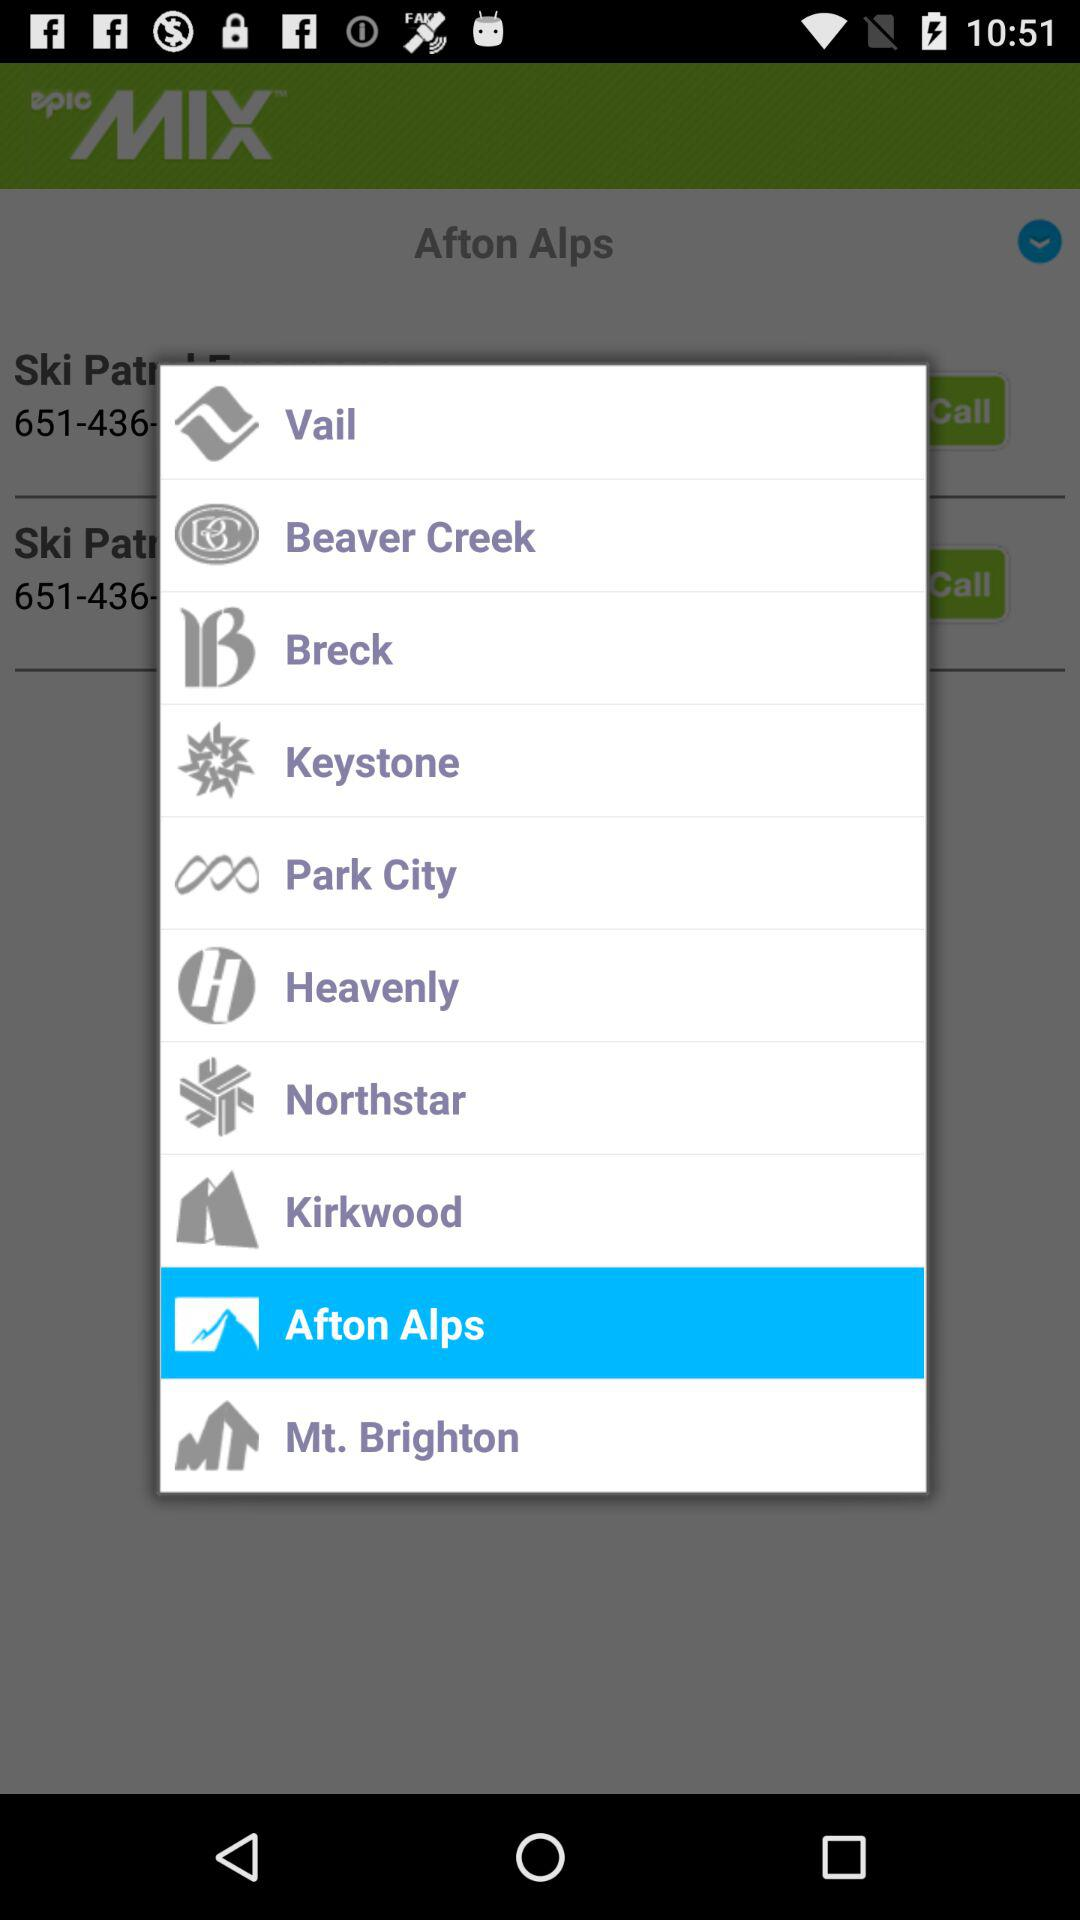Which is the selected option? The selected option is "Afton Alps". 